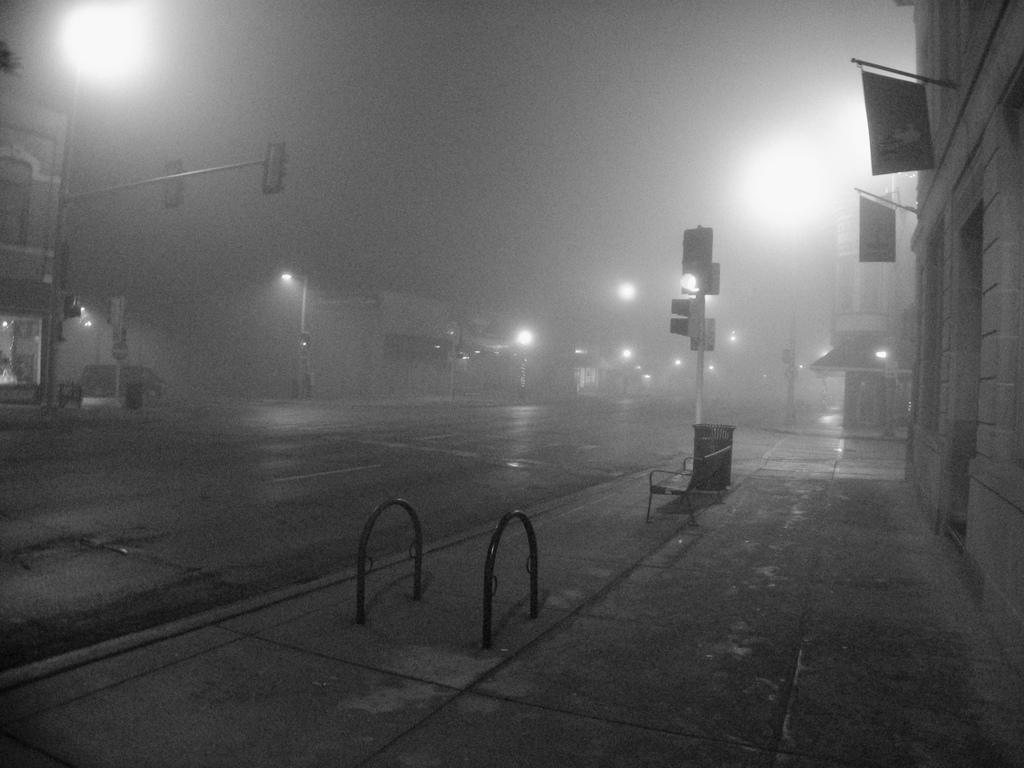What type of structures can be seen in the image? There are many buildings in the image. What can be seen illuminating the scene in the image? There are lights in the image. What device is used to control traffic in the image? There is a traffic signal in the image. What type of pathway is visible in the image? There is a road in the image. What is the color scheme of the image? The image is black and white. What type of shirt is being worn by the traffic signal in the image? There is no shirt present in the image, as the traffic signal is an inanimate object. What type of dinner is being served in the image? There is no dinner present in the image; it features buildings, lights, a traffic signal, and a road. 